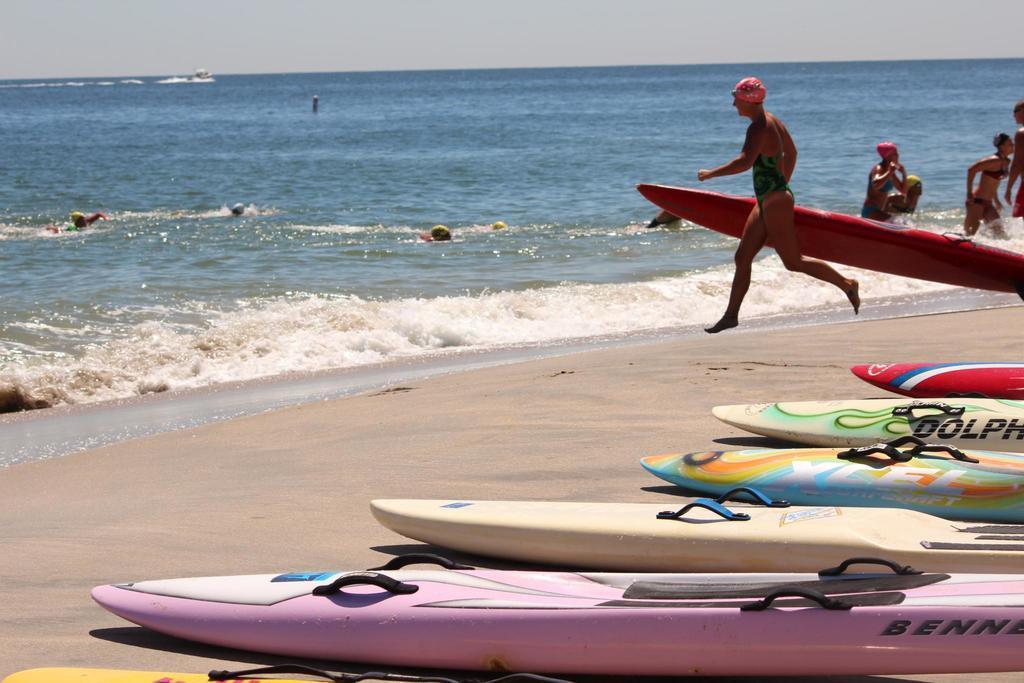<image>
Write a terse but informative summary of the picture. Surfboards lie in a row on a beach, one of them with part of the word Dolphin on it. 